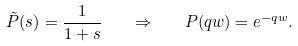Convert formula to latex. <formula><loc_0><loc_0><loc_500><loc_500>\tilde { P } ( s ) = \frac { 1 } { 1 + s } \quad \Rightarrow \quad P ( q w ) = e ^ { - q w } .</formula> 